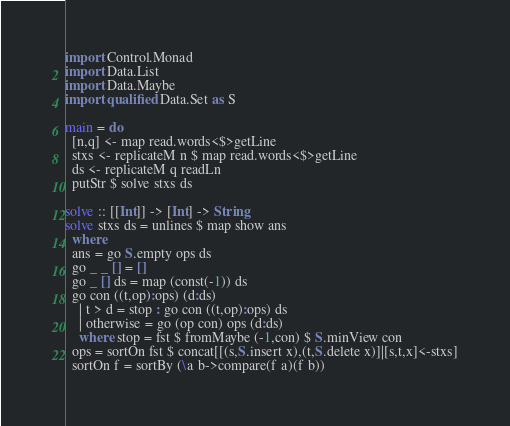<code> <loc_0><loc_0><loc_500><loc_500><_Haskell_>import Control.Monad
import Data.List
import Data.Maybe
import qualified Data.Set as S

main = do
  [n,q] <- map read.words<$>getLine
  stxs <- replicateM n $ map read.words<$>getLine
  ds <- replicateM q readLn
  putStr $ solve stxs ds

solve :: [[Int]] -> [Int] -> String
solve stxs ds = unlines $ map show ans
  where
  ans = go S.empty ops ds
  go _ _ [] = []
  go _ [] ds = map (const(-1)) ds
  go con ((t,op):ops) (d:ds)
    | t > d = stop : go con ((t,op):ops) ds
    | otherwise = go (op con) ops (d:ds)
    where stop = fst $ fromMaybe (-1,con) $ S.minView con
  ops = sortOn fst $ concat[[(s,S.insert x),(t,S.delete x)]|[s,t,x]<-stxs]
  sortOn f = sortBy (\a b->compare(f a)(f b))</code> 